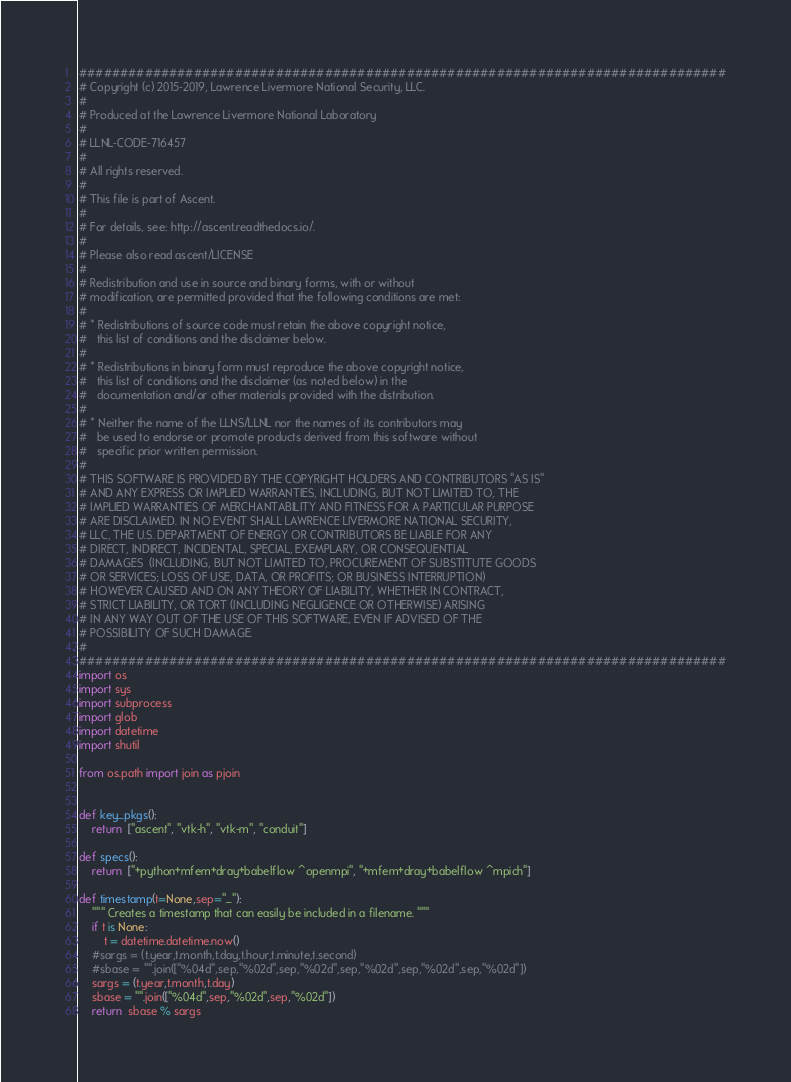<code> <loc_0><loc_0><loc_500><loc_500><_Python_>###############################################################################
# Copyright (c) 2015-2019, Lawrence Livermore National Security, LLC.
#
# Produced at the Lawrence Livermore National Laboratory
#
# LLNL-CODE-716457
#
# All rights reserved.
#
# This file is part of Ascent.
#
# For details, see: http://ascent.readthedocs.io/.
#
# Please also read ascent/LICENSE
#
# Redistribution and use in source and binary forms, with or without
# modification, are permitted provided that the following conditions are met:
#
# * Redistributions of source code must retain the above copyright notice,
#   this list of conditions and the disclaimer below.
#
# * Redistributions in binary form must reproduce the above copyright notice,
#   this list of conditions and the disclaimer (as noted below) in the
#   documentation and/or other materials provided with the distribution.
#
# * Neither the name of the LLNS/LLNL nor the names of its contributors may
#   be used to endorse or promote products derived from this software without
#   specific prior written permission.
#
# THIS SOFTWARE IS PROVIDED BY THE COPYRIGHT HOLDERS AND CONTRIBUTORS "AS IS"
# AND ANY EXPRESS OR IMPLIED WARRANTIES, INCLUDING, BUT NOT LIMITED TO, THE
# IMPLIED WARRANTIES OF MERCHANTABILITY AND FITNESS FOR A PARTICULAR PURPOSE
# ARE DISCLAIMED. IN NO EVENT SHALL LAWRENCE LIVERMORE NATIONAL SECURITY,
# LLC, THE U.S. DEPARTMENT OF ENERGY OR CONTRIBUTORS BE LIABLE FOR ANY
# DIRECT, INDIRECT, INCIDENTAL, SPECIAL, EXEMPLARY, OR CONSEQUENTIAL
# DAMAGES  (INCLUDING, BUT NOT LIMITED TO, PROCUREMENT OF SUBSTITUTE GOODS
# OR SERVICES; LOSS OF USE, DATA, OR PROFITS; OR BUSINESS INTERRUPTION)
# HOWEVER CAUSED AND ON ANY THEORY OF LIABILITY, WHETHER IN CONTRACT,
# STRICT LIABILITY, OR TORT (INCLUDING NEGLIGENCE OR OTHERWISE) ARISING
# IN ANY WAY OUT OF THE USE OF THIS SOFTWARE, EVEN IF ADVISED OF THE
# POSSIBILITY OF SUCH DAMAGE.
#
###############################################################################
import os
import sys
import subprocess
import glob
import datetime
import shutil

from os.path import join as pjoin


def key_pkgs():
    return  ["ascent", "vtk-h", "vtk-m", "conduit"]

def specs():
    return  ["+python+mfem+dray+babelflow ^openmpi", "+mfem+dray+babelflow ^mpich"]

def timestamp(t=None,sep="_"):
    """ Creates a timestamp that can easily be included in a filename. """
    if t is None:
        t = datetime.datetime.now()
    #sargs = (t.year,t.month,t.day,t.hour,t.minute,t.second)
    #sbase = "".join(["%04d",sep,"%02d",sep,"%02d",sep,"%02d",sep,"%02d",sep,"%02d"])
    sargs = (t.year,t.month,t.day)
    sbase = "".join(["%04d",sep,"%02d",sep,"%02d"])
    return  sbase % sargs
</code> 